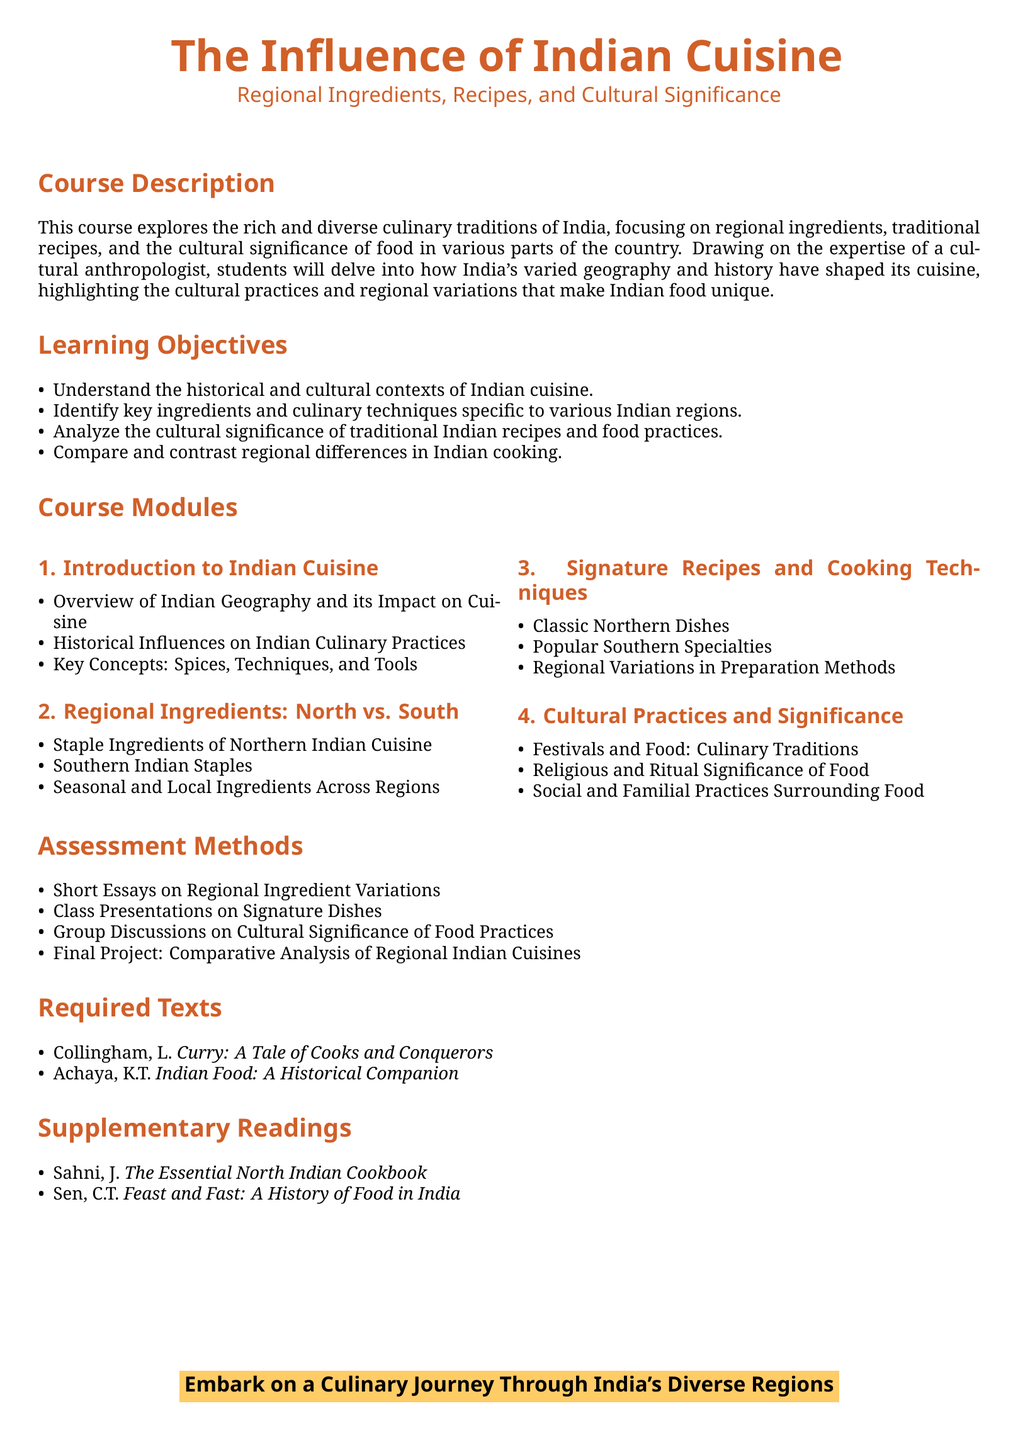What is the course title? The course title is the main heading of the syllabus document.
Answer: The Influence of Indian Cuisine What are two required texts for the course? The required texts are listed under the "Required Texts" section.
Answer: Curry: A Tale of Cooks and Conquerors; Indian Food: A Historical Companion How many learning objectives are outlined in the document? The number of learning objectives is stated in the "Learning Objectives" section.
Answer: Four What is the focus of the second module? The focus of the second module is detailed in the "Course Modules" section.
Answer: Regional Ingredients: North vs. South What is the final project type for assessment? The final project type is specified in the "Assessment Methods" section.
Answer: Comparative Analysis of Regional Indian Cuisines 